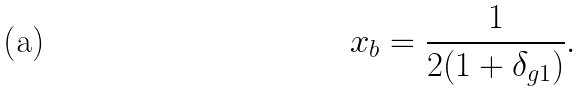Convert formula to latex. <formula><loc_0><loc_0><loc_500><loc_500>x _ { b } = \frac { 1 } { 2 ( 1 + \delta _ { g 1 } ) } .</formula> 